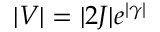Convert formula to latex. <formula><loc_0><loc_0><loc_500><loc_500>| V | = | 2 J | e ^ { | \gamma | }</formula> 